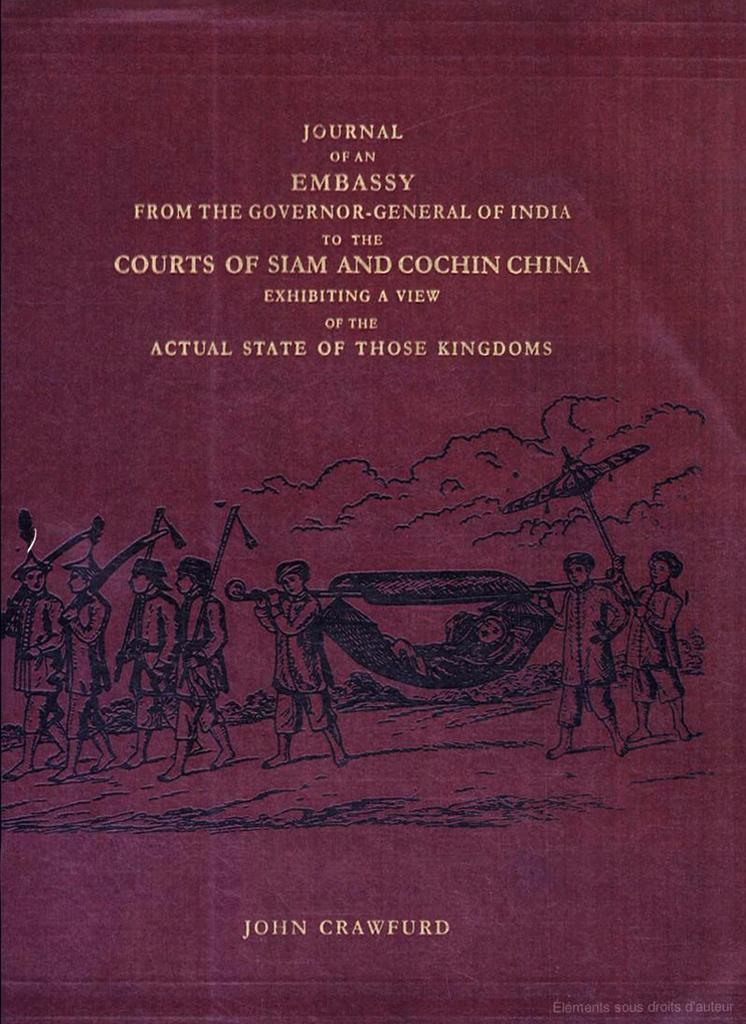What is the main subject in the center of the image? There is a poster in the center of the image. What can be found on the poster? The poster contains text and depictions of persons. What type of surprise can be seen on the ship in the image? There is no ship or surprise present in the image; it only features a poster with text and depictions of persons. 